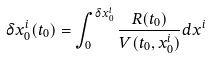<formula> <loc_0><loc_0><loc_500><loc_500>\delta { x } ^ { i } _ { 0 } ( { t } _ { 0 } ) = \int _ { 0 } ^ { \delta { x } ^ { i } _ { 0 } } { \frac { R ( { t } _ { 0 } ) } { V ( { t } _ { 0 } , { x } ^ { i } _ { 0 } ) } d { x } ^ { i } }</formula> 